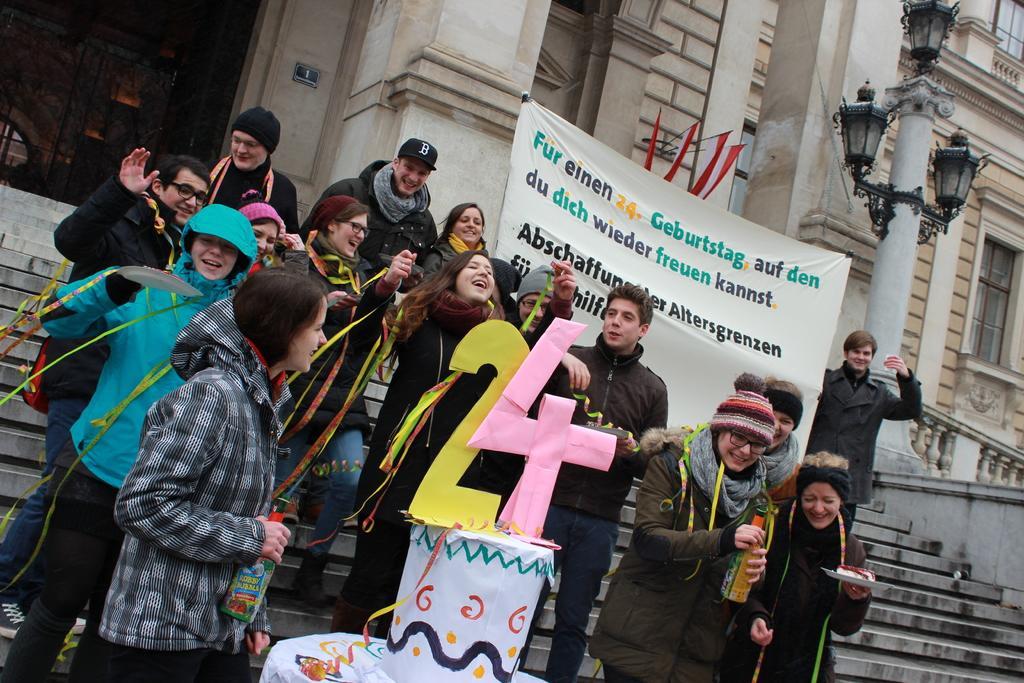Describe this image in one or two sentences. In this picture there are group of people standing and smiling and there are two persons standing and holding the bottles and there are three persons standing and holding the plates. In the foreground there is a box on the table. At the back there is a banner and there is a text on the banner. There are flags on the wall and there are lights on the pole. On the left side of the image there is a door. 